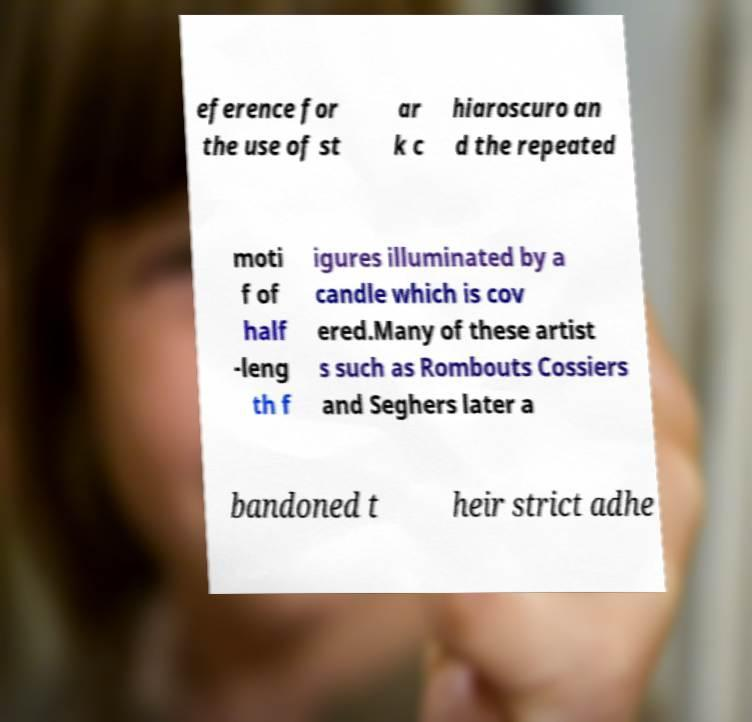What messages or text are displayed in this image? I need them in a readable, typed format. eference for the use of st ar k c hiaroscuro an d the repeated moti f of half -leng th f igures illuminated by a candle which is cov ered.Many of these artist s such as Rombouts Cossiers and Seghers later a bandoned t heir strict adhe 